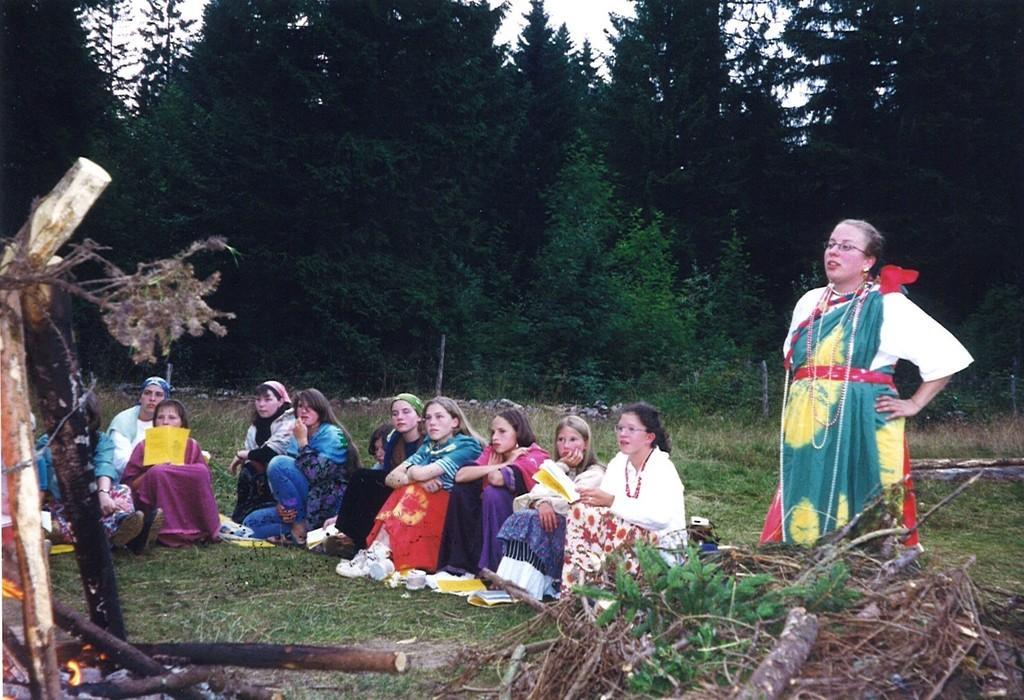Describe this image in one or two sentences. In this image in the left there is campfire. In the bottom there are sticks. In the ground few ladies are sitting. In the right a lady is standing. In the background there are trees and sky. 